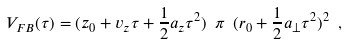Convert formula to latex. <formula><loc_0><loc_0><loc_500><loc_500>V _ { F B } ( \tau ) = ( z _ { 0 } + v _ { z } \tau + \frac { 1 } { 2 } a _ { z } \tau ^ { 2 } ) \ \pi \ ( r _ { 0 } + \frac { 1 } { 2 } a _ { \perp } \tau ^ { 2 } ) ^ { 2 } \ ,</formula> 